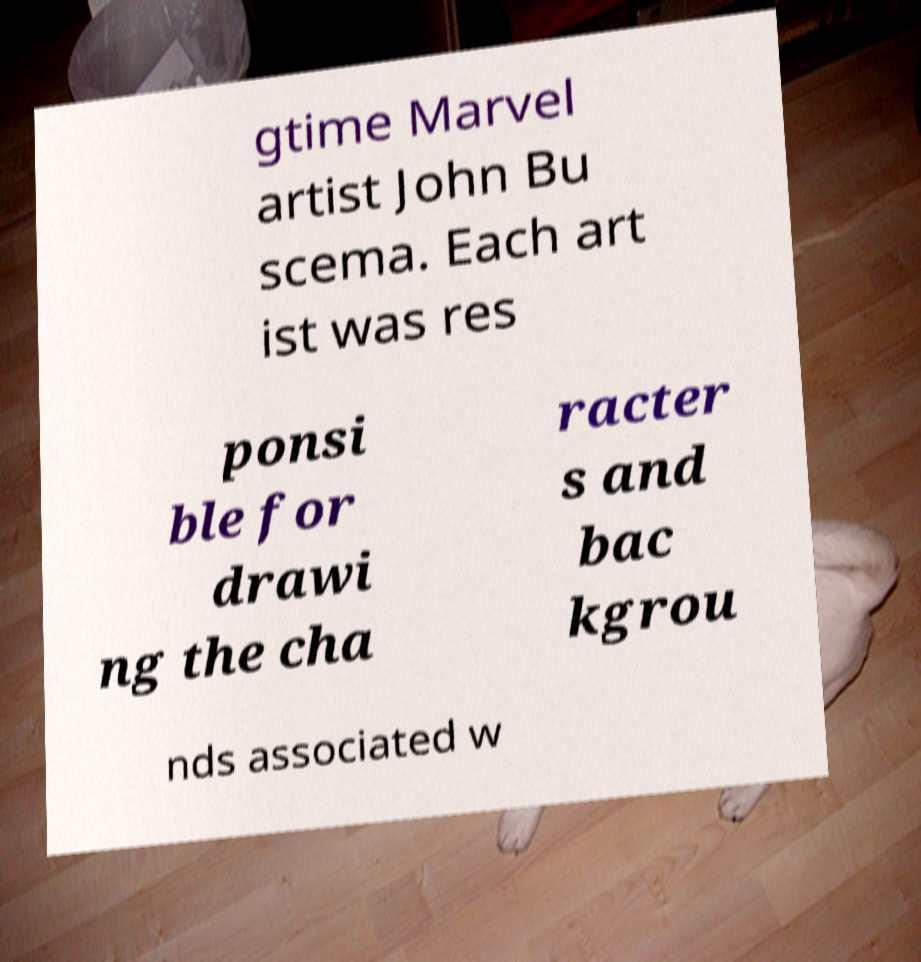Please read and relay the text visible in this image. What does it say? gtime Marvel artist John Bu scema. Each art ist was res ponsi ble for drawi ng the cha racter s and bac kgrou nds associated w 